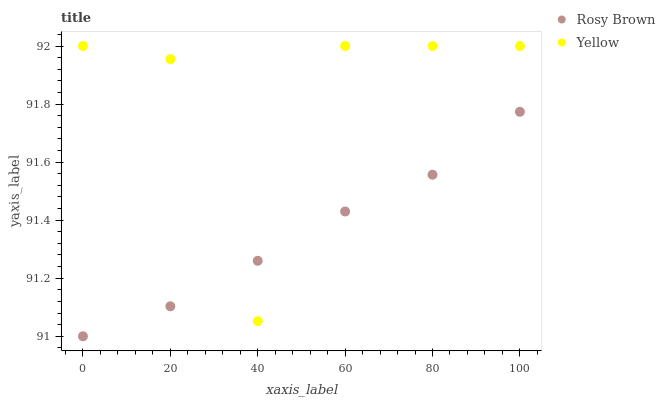Does Rosy Brown have the minimum area under the curve?
Answer yes or no. Yes. Does Yellow have the maximum area under the curve?
Answer yes or no. Yes. Does Yellow have the minimum area under the curve?
Answer yes or no. No. Is Rosy Brown the smoothest?
Answer yes or no. Yes. Is Yellow the roughest?
Answer yes or no. Yes. Is Yellow the smoothest?
Answer yes or no. No. Does Rosy Brown have the lowest value?
Answer yes or no. Yes. Does Yellow have the lowest value?
Answer yes or no. No. Does Yellow have the highest value?
Answer yes or no. Yes. Does Yellow intersect Rosy Brown?
Answer yes or no. Yes. Is Yellow less than Rosy Brown?
Answer yes or no. No. Is Yellow greater than Rosy Brown?
Answer yes or no. No. 